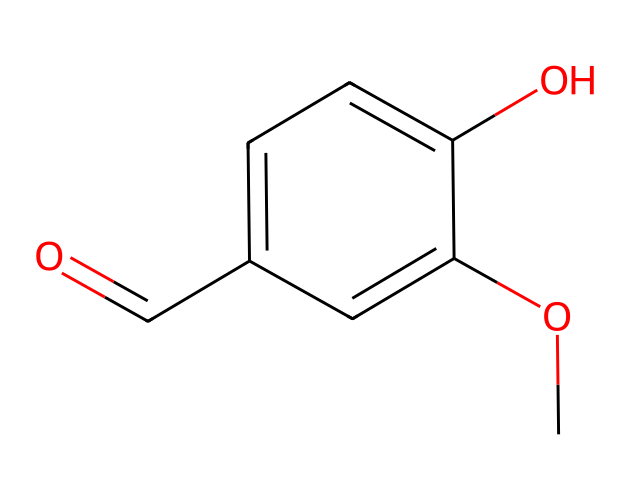What is the molecular formula of vanillin? To determine the molecular formula, we count the number of each type of atom in the SMILES representation. The given SMILES contains 8 carbon (C) atoms, 8 hydrogen (H) atoms, and 3 oxygen (O) atoms. Thus, the molecular formula is C8H8O3.
Answer: C8H8O3 How many benzene rings are present in the structure? The structure contains a single aromatic ring which can be identified from the 'c' notation in the SMILES. Therefore, there is one benzene ring in vanillin.
Answer: 1 Which functional groups are present in vanillin? By analyzing the structure, we can see that vanillin contains a methoxy group (-OCH3) and an aldehyde group (-CHO). These are the key functional groups in this chemical.
Answer: methoxy and aldehyde What is the role of the methoxy group in vanillin? The methoxy group enhances the volatility of the compound, making it more fragrant. Such groups can contribute to the aroma characteristics important for flavors and fragrances.
Answer: enhances volatility How would you categorize vanillin based on its fragrance profile? Vanillin is often categorized as a sweet and creamy fragrance due to its structure that resembles the aroma of vanilla. This sweet scent makes it popular in perfumes and flavorings.
Answer: sweet and creamy What is the significance of vanillin in counterfeit artifact investigation? In counterfeit artifacts, vanillin may be used to mimic the scent of genuine materials, leading to misidentification. Its presence can indicate if an artifact has been artificially modified.
Answer: misidentification 